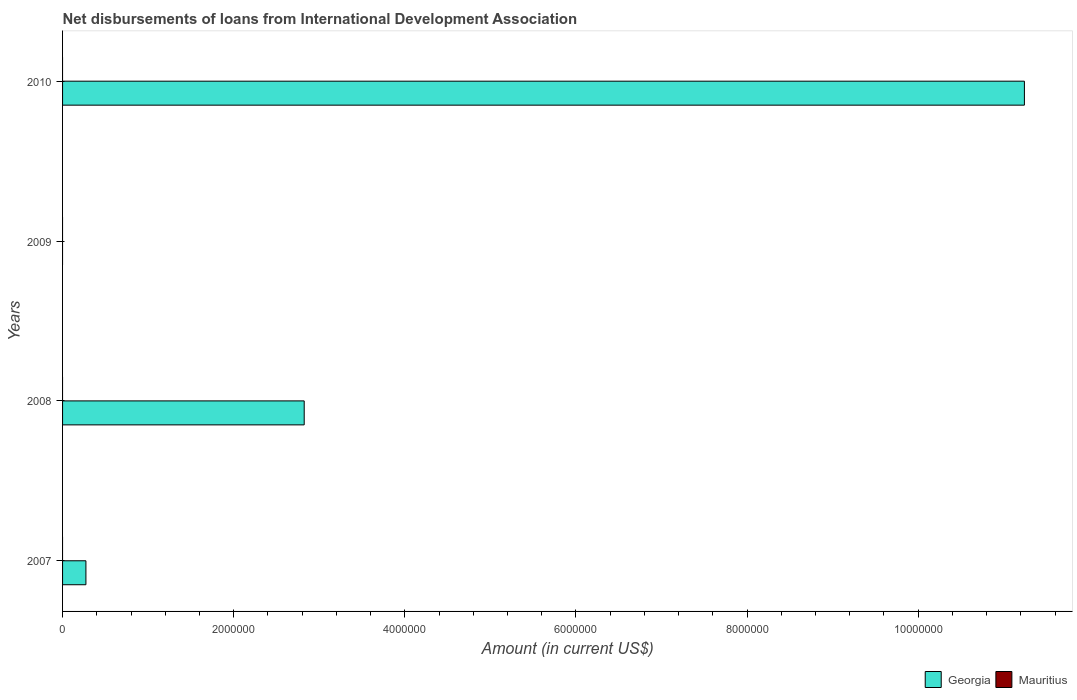Are the number of bars per tick equal to the number of legend labels?
Provide a succinct answer. No. Are the number of bars on each tick of the Y-axis equal?
Give a very brief answer. No. How many bars are there on the 3rd tick from the top?
Offer a terse response. 1. How many bars are there on the 3rd tick from the bottom?
Offer a very short reply. 0. What is the label of the 3rd group of bars from the top?
Provide a succinct answer. 2008. In how many cases, is the number of bars for a given year not equal to the number of legend labels?
Offer a terse response. 4. What is the amount of loans disbursed in Georgia in 2008?
Give a very brief answer. 2.82e+06. Across all years, what is the maximum amount of loans disbursed in Georgia?
Your response must be concise. 1.12e+07. In which year was the amount of loans disbursed in Georgia maximum?
Make the answer very short. 2010. What is the total amount of loans disbursed in Georgia in the graph?
Your answer should be compact. 1.43e+07. What is the difference between the amount of loans disbursed in Georgia in 2007 and that in 2010?
Your response must be concise. -1.10e+07. What is the difference between the amount of loans disbursed in Georgia in 2009 and the amount of loans disbursed in Mauritius in 2007?
Provide a short and direct response. 0. What is the average amount of loans disbursed in Georgia per year?
Offer a very short reply. 3.58e+06. In how many years, is the amount of loans disbursed in Georgia greater than 4000000 US$?
Ensure brevity in your answer.  1. What is the difference between the highest and the second highest amount of loans disbursed in Georgia?
Your answer should be compact. 8.42e+06. What is the difference between the highest and the lowest amount of loans disbursed in Georgia?
Offer a very short reply. 1.12e+07. In how many years, is the amount of loans disbursed in Mauritius greater than the average amount of loans disbursed in Mauritius taken over all years?
Your response must be concise. 0. How many bars are there?
Keep it short and to the point. 3. Are all the bars in the graph horizontal?
Make the answer very short. Yes. How many years are there in the graph?
Give a very brief answer. 4. What is the difference between two consecutive major ticks on the X-axis?
Your answer should be compact. 2.00e+06. Are the values on the major ticks of X-axis written in scientific E-notation?
Offer a very short reply. No. Does the graph contain any zero values?
Make the answer very short. Yes. Does the graph contain grids?
Your answer should be compact. No. How many legend labels are there?
Your answer should be compact. 2. What is the title of the graph?
Offer a terse response. Net disbursements of loans from International Development Association. What is the Amount (in current US$) of Georgia in 2007?
Make the answer very short. 2.73e+05. What is the Amount (in current US$) of Mauritius in 2007?
Give a very brief answer. 0. What is the Amount (in current US$) in Georgia in 2008?
Your response must be concise. 2.82e+06. What is the Amount (in current US$) of Georgia in 2009?
Provide a short and direct response. 0. What is the Amount (in current US$) in Mauritius in 2009?
Keep it short and to the point. 0. What is the Amount (in current US$) of Georgia in 2010?
Your answer should be very brief. 1.12e+07. What is the Amount (in current US$) of Mauritius in 2010?
Your answer should be very brief. 0. Across all years, what is the maximum Amount (in current US$) of Georgia?
Your answer should be very brief. 1.12e+07. What is the total Amount (in current US$) in Georgia in the graph?
Make the answer very short. 1.43e+07. What is the difference between the Amount (in current US$) of Georgia in 2007 and that in 2008?
Make the answer very short. -2.55e+06. What is the difference between the Amount (in current US$) of Georgia in 2007 and that in 2010?
Your answer should be compact. -1.10e+07. What is the difference between the Amount (in current US$) in Georgia in 2008 and that in 2010?
Provide a short and direct response. -8.42e+06. What is the average Amount (in current US$) of Georgia per year?
Provide a short and direct response. 3.58e+06. What is the average Amount (in current US$) in Mauritius per year?
Your response must be concise. 0. What is the ratio of the Amount (in current US$) of Georgia in 2007 to that in 2008?
Provide a succinct answer. 0.1. What is the ratio of the Amount (in current US$) in Georgia in 2007 to that in 2010?
Ensure brevity in your answer.  0.02. What is the ratio of the Amount (in current US$) in Georgia in 2008 to that in 2010?
Give a very brief answer. 0.25. What is the difference between the highest and the second highest Amount (in current US$) of Georgia?
Your response must be concise. 8.42e+06. What is the difference between the highest and the lowest Amount (in current US$) of Georgia?
Provide a short and direct response. 1.12e+07. 